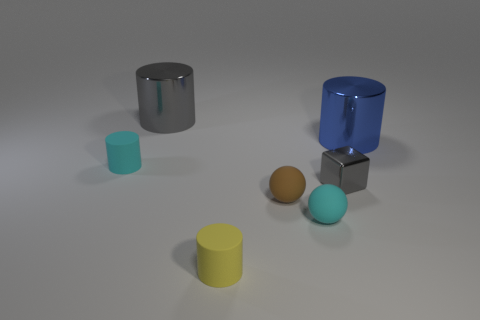Subtract all small yellow rubber cylinders. How many cylinders are left? 3 Subtract all blue cylinders. How many cylinders are left? 3 Subtract 2 cylinders. How many cylinders are left? 2 Add 1 small rubber objects. How many objects exist? 8 Subtract all gray cylinders. Subtract all green blocks. How many cylinders are left? 3 Subtract all spheres. How many objects are left? 5 Add 6 gray shiny cubes. How many gray shiny cubes are left? 7 Add 7 big metal cubes. How many big metal cubes exist? 7 Subtract 0 red balls. How many objects are left? 7 Subtract all cyan cylinders. Subtract all big cylinders. How many objects are left? 4 